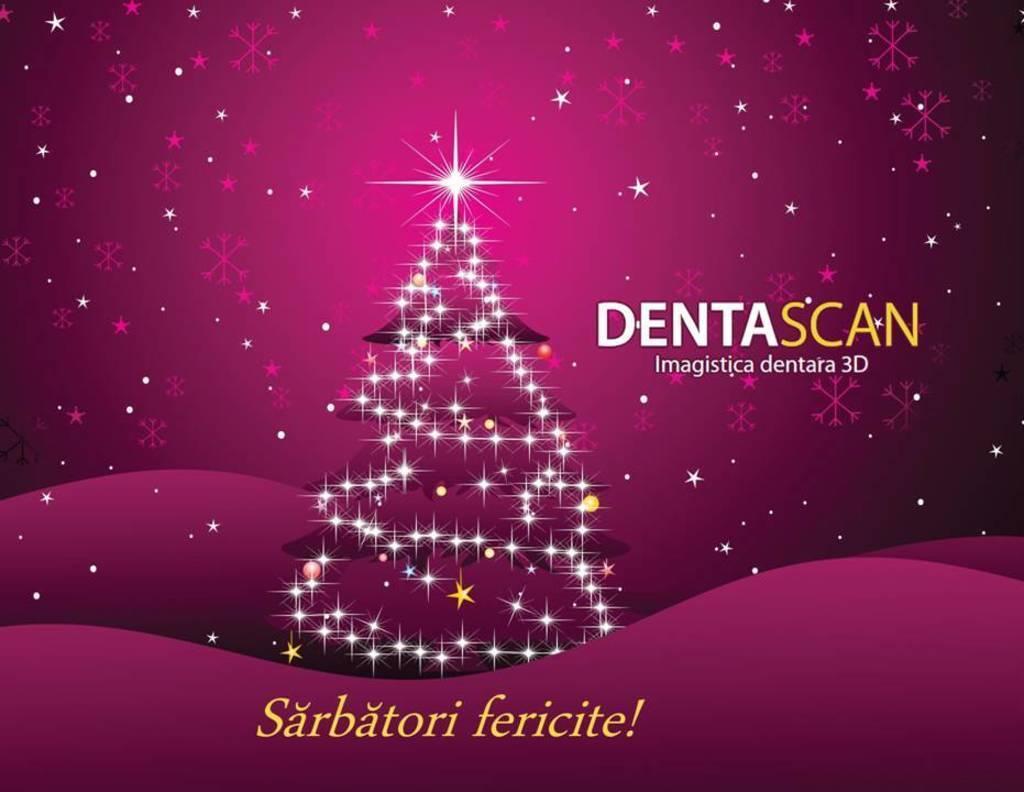Can you describe this image briefly? This is a poster, here we can see a Christmas tree, lights and some text on it. 